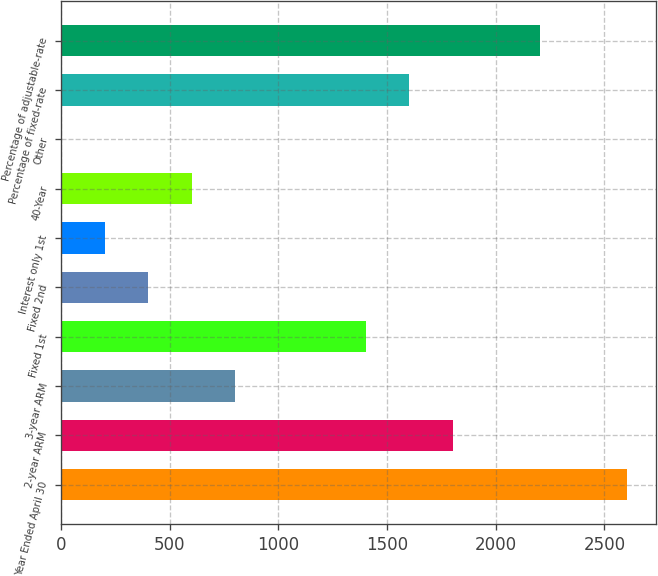Convert chart. <chart><loc_0><loc_0><loc_500><loc_500><bar_chart><fcel>Year Ended April 30<fcel>2-year ARM<fcel>3-year ARM<fcel>Fixed 1st<fcel>Fixed 2nd<fcel>Interest only 1st<fcel>40-Year<fcel>Other<fcel>Percentage of fixed-rate<fcel>Percentage of adjustable-rate<nl><fcel>2605.08<fcel>1803.64<fcel>801.84<fcel>1402.92<fcel>401.12<fcel>200.76<fcel>601.48<fcel>0.4<fcel>1603.28<fcel>2204.36<nl></chart> 